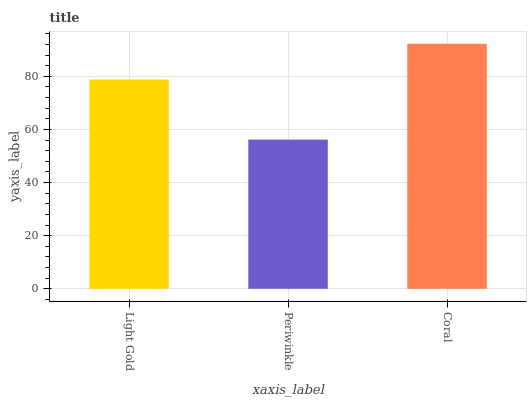Is Coral the minimum?
Answer yes or no. No. Is Periwinkle the maximum?
Answer yes or no. No. Is Coral greater than Periwinkle?
Answer yes or no. Yes. Is Periwinkle less than Coral?
Answer yes or no. Yes. Is Periwinkle greater than Coral?
Answer yes or no. No. Is Coral less than Periwinkle?
Answer yes or no. No. Is Light Gold the high median?
Answer yes or no. Yes. Is Light Gold the low median?
Answer yes or no. Yes. Is Coral the high median?
Answer yes or no. No. Is Coral the low median?
Answer yes or no. No. 